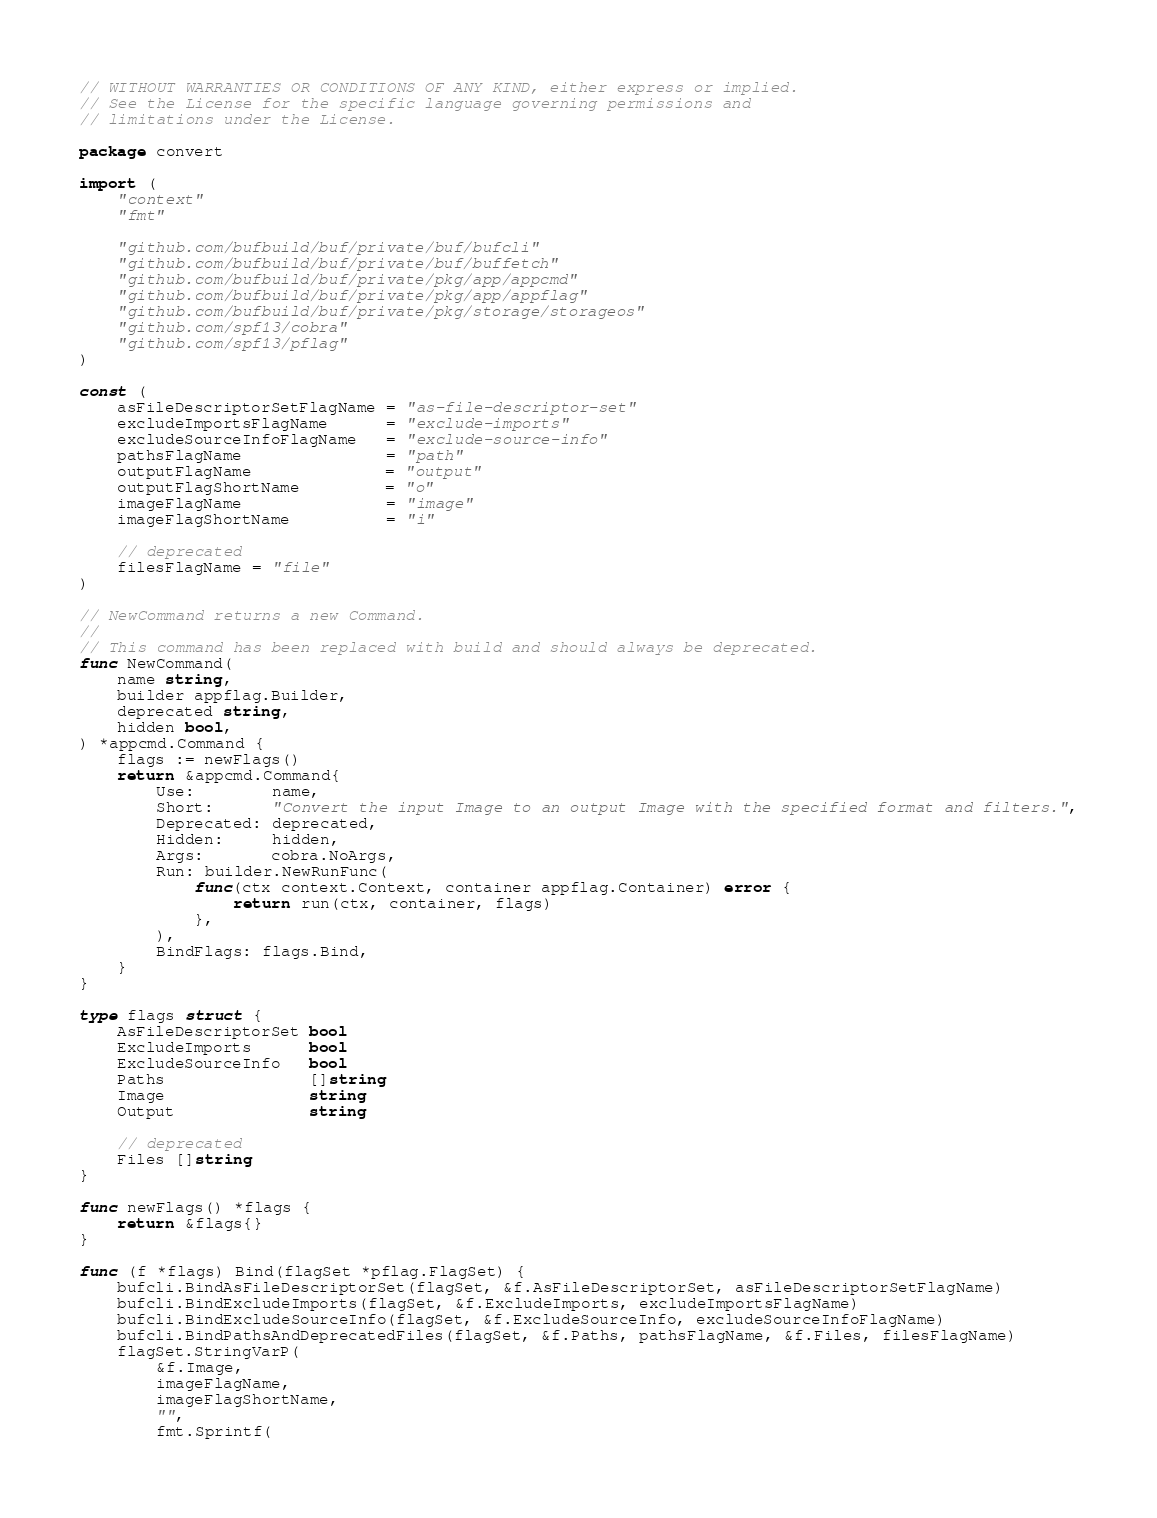Convert code to text. <code><loc_0><loc_0><loc_500><loc_500><_Go_>// WITHOUT WARRANTIES OR CONDITIONS OF ANY KIND, either express or implied.
// See the License for the specific language governing permissions and
// limitations under the License.

package convert

import (
	"context"
	"fmt"

	"github.com/bufbuild/buf/private/buf/bufcli"
	"github.com/bufbuild/buf/private/buf/buffetch"
	"github.com/bufbuild/buf/private/pkg/app/appcmd"
	"github.com/bufbuild/buf/private/pkg/app/appflag"
	"github.com/bufbuild/buf/private/pkg/storage/storageos"
	"github.com/spf13/cobra"
	"github.com/spf13/pflag"
)

const (
	asFileDescriptorSetFlagName = "as-file-descriptor-set"
	excludeImportsFlagName      = "exclude-imports"
	excludeSourceInfoFlagName   = "exclude-source-info"
	pathsFlagName               = "path"
	outputFlagName              = "output"
	outputFlagShortName         = "o"
	imageFlagName               = "image"
	imageFlagShortName          = "i"

	// deprecated
	filesFlagName = "file"
)

// NewCommand returns a new Command.
//
// This command has been replaced with build and should always be deprecated.
func NewCommand(
	name string,
	builder appflag.Builder,
	deprecated string,
	hidden bool,
) *appcmd.Command {
	flags := newFlags()
	return &appcmd.Command{
		Use:        name,
		Short:      "Convert the input Image to an output Image with the specified format and filters.",
		Deprecated: deprecated,
		Hidden:     hidden,
		Args:       cobra.NoArgs,
		Run: builder.NewRunFunc(
			func(ctx context.Context, container appflag.Container) error {
				return run(ctx, container, flags)
			},
		),
		BindFlags: flags.Bind,
	}
}

type flags struct {
	AsFileDescriptorSet bool
	ExcludeImports      bool
	ExcludeSourceInfo   bool
	Paths               []string
	Image               string
	Output              string

	// deprecated
	Files []string
}

func newFlags() *flags {
	return &flags{}
}

func (f *flags) Bind(flagSet *pflag.FlagSet) {
	bufcli.BindAsFileDescriptorSet(flagSet, &f.AsFileDescriptorSet, asFileDescriptorSetFlagName)
	bufcli.BindExcludeImports(flagSet, &f.ExcludeImports, excludeImportsFlagName)
	bufcli.BindExcludeSourceInfo(flagSet, &f.ExcludeSourceInfo, excludeSourceInfoFlagName)
	bufcli.BindPathsAndDeprecatedFiles(flagSet, &f.Paths, pathsFlagName, &f.Files, filesFlagName)
	flagSet.StringVarP(
		&f.Image,
		imageFlagName,
		imageFlagShortName,
		"",
		fmt.Sprintf(</code> 